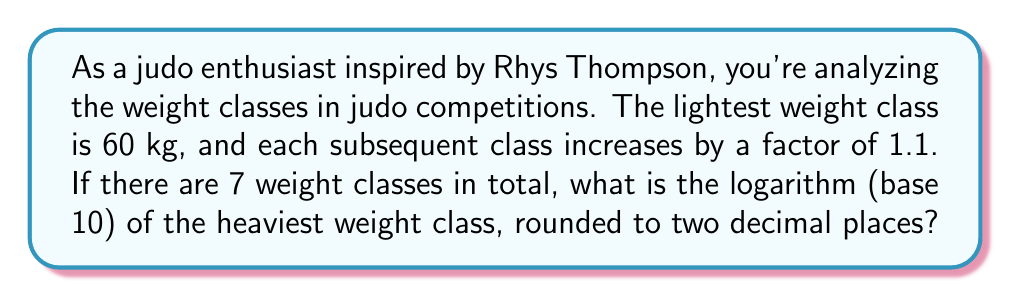Could you help me with this problem? Let's approach this step-by-step:

1) First, we need to find the weight of the heaviest class. We can do this by multiplying 60 kg by 1.1 six times (as there are 7 classes in total).

2) We can express this mathematically as:
   $$ 60 \times 1.1^6 $$

3) Let's calculate this:
   $$ 60 \times 1.1^6 = 60 \times 1.771561 = 106.29366 \text{ kg} $$

4) Now, we need to find the logarithm (base 10) of this value:
   $$ \log_{10}(106.29366) $$

5) Using a calculator or logarithm table:
   $$ \log_{10}(106.29366) \approx 2.02657 $$

6) Rounding to two decimal places:
   $$ 2.02657 \approx 2.03 $$

Therefore, the logarithm (base 10) of the heaviest weight class, rounded to two decimal places, is 2.03.
Answer: 2.03 